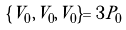Convert formula to latex. <formula><loc_0><loc_0><loc_500><loc_500>\{ V _ { 0 } , V _ { 0 } , V _ { 0 } \} = 3 P _ { 0 }</formula> 